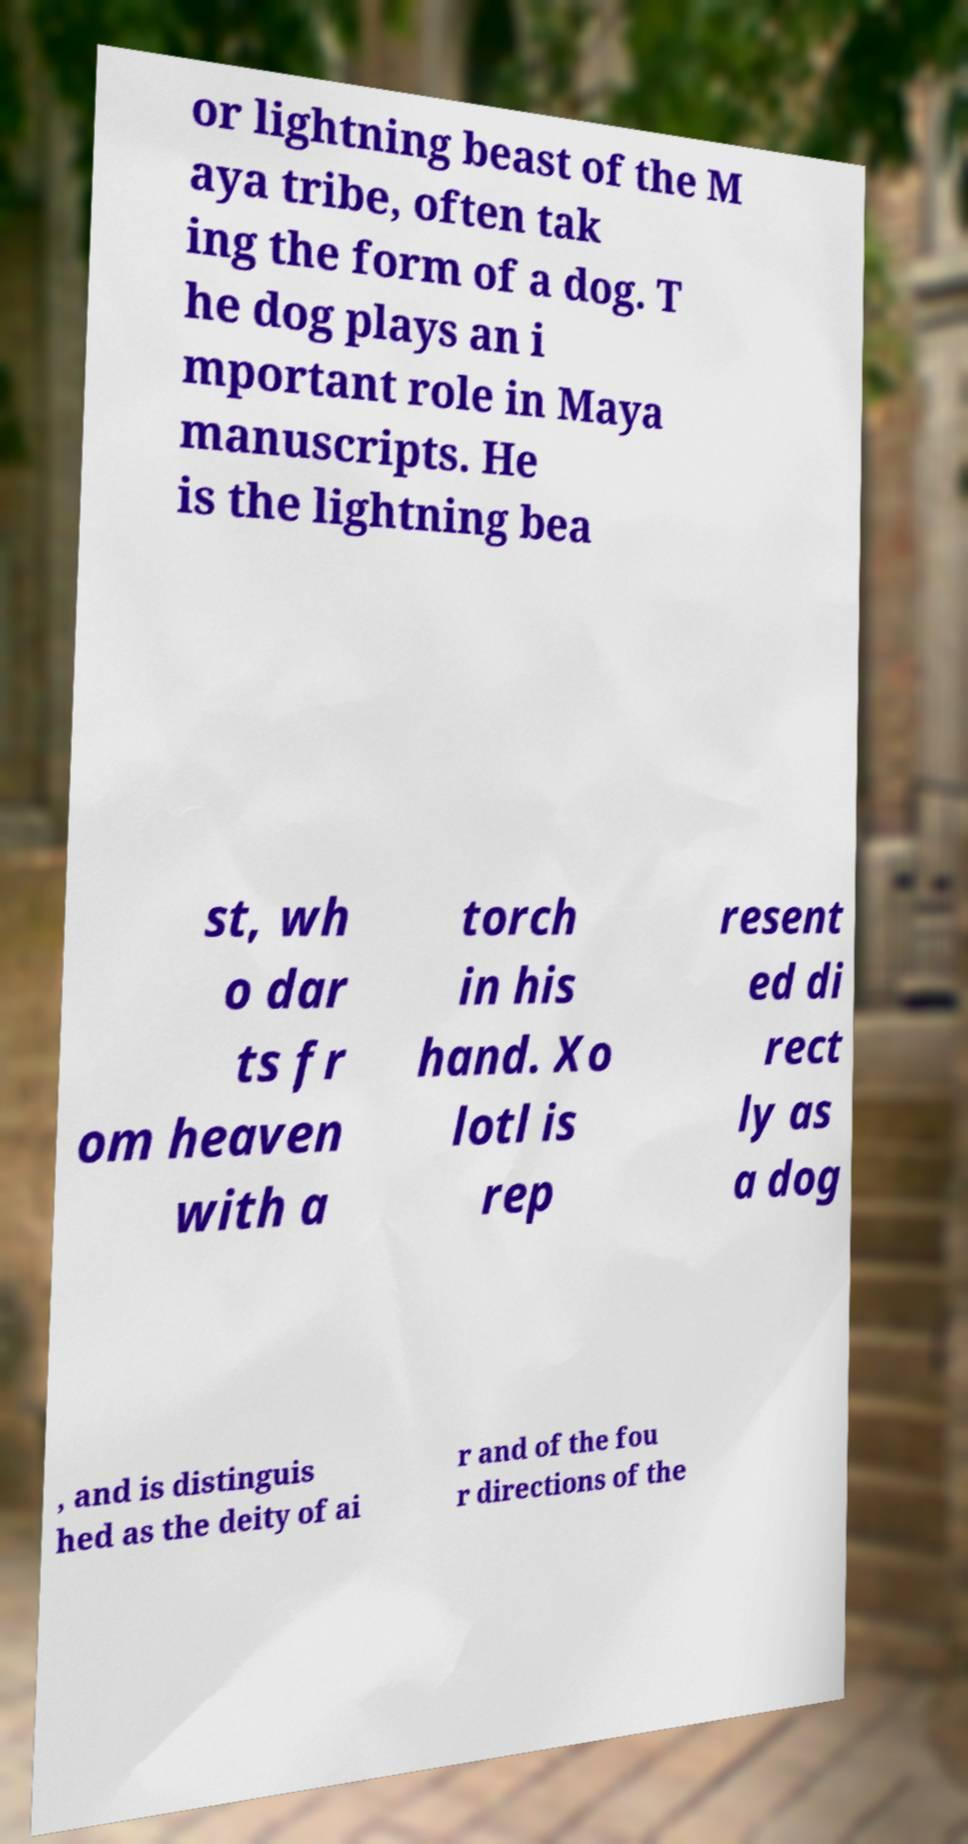Could you extract and type out the text from this image? or lightning beast of the M aya tribe, often tak ing the form of a dog. T he dog plays an i mportant role in Maya manuscripts. He is the lightning bea st, wh o dar ts fr om heaven with a torch in his hand. Xo lotl is rep resent ed di rect ly as a dog , and is distinguis hed as the deity of ai r and of the fou r directions of the 